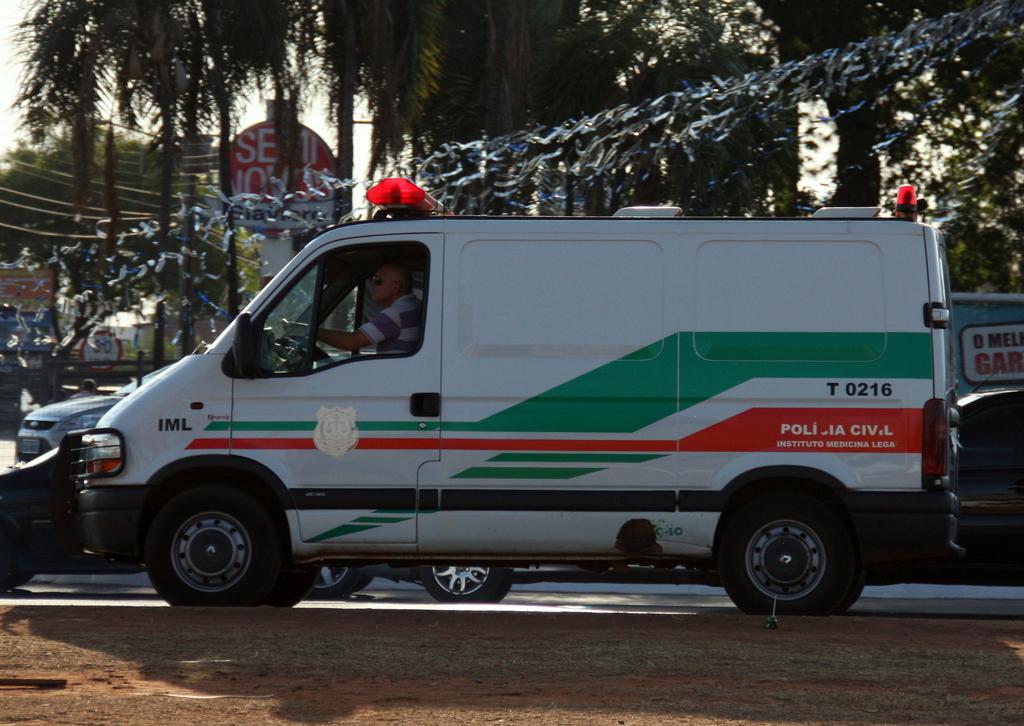What is the van number?
Your response must be concise. T 0216. 